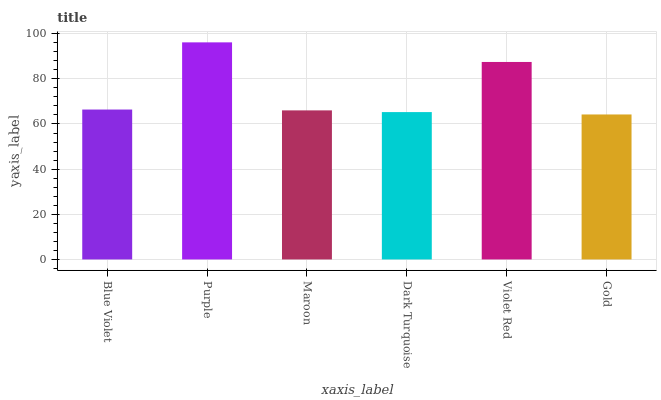Is Gold the minimum?
Answer yes or no. Yes. Is Purple the maximum?
Answer yes or no. Yes. Is Maroon the minimum?
Answer yes or no. No. Is Maroon the maximum?
Answer yes or no. No. Is Purple greater than Maroon?
Answer yes or no. Yes. Is Maroon less than Purple?
Answer yes or no. Yes. Is Maroon greater than Purple?
Answer yes or no. No. Is Purple less than Maroon?
Answer yes or no. No. Is Blue Violet the high median?
Answer yes or no. Yes. Is Maroon the low median?
Answer yes or no. Yes. Is Gold the high median?
Answer yes or no. No. Is Purple the low median?
Answer yes or no. No. 